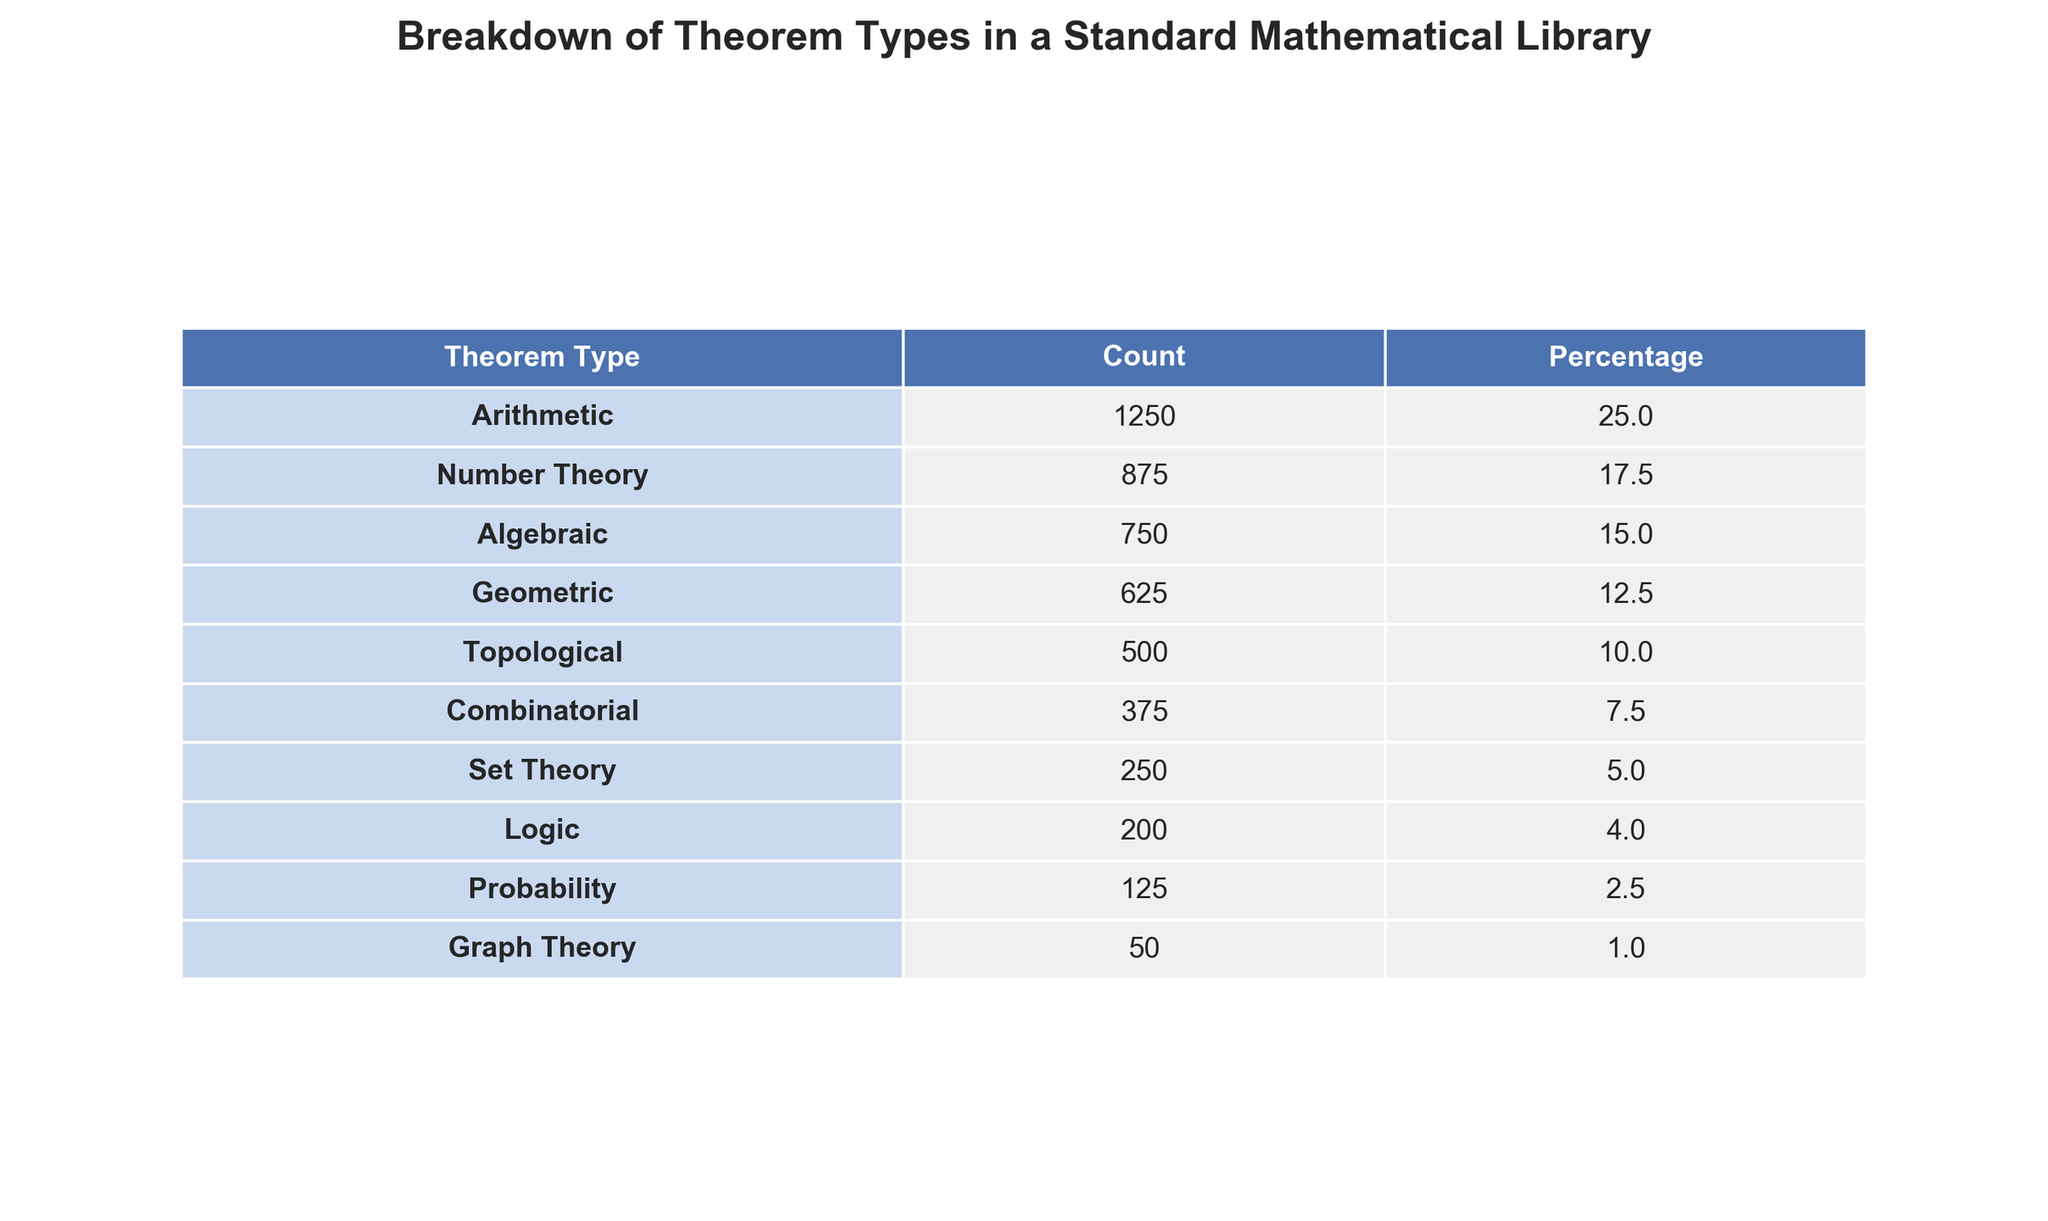What is the count of Theorems in Algebraic type? The count of Theorems in the Algebraic type is directly listed in the table under the Count column, which shows 750.
Answer: 750 Which theorem type has the highest percentage? By observing the Percentage column, Arithmetic has the highest value at 25.0%.
Answer: Arithmetic What is the total number of Theorems listed in the table? The total number of Theorems can be found by summing all the counts in the Count column: 1250 + 875 + 750 + 625 + 500 + 375 + 250 + 200 + 125 + 50 = 5000.
Answer: 5000 Is the count of Logic Theorems greater than that of Probability Theorems? Comparing the counts in the table, Logic has 200 Theorems and Probability has 125, thus 200 > 125 is true.
Answer: Yes What is the percentage difference between the highest and lowest theorem types? The highest theorem type, Arithmetic, has 25.0% and the lowest, Graph Theory, has 1.0%. The difference is 25.0% - 1.0% = 24.0%.
Answer: 24.0% If we combine the counts of Combinatorial and Set Theory files, what is the total? The count for Combinatorial is 375 and for Set Theory it is 250. Summing these gives 375 + 250 = 625.
Answer: 625 How many theorem types have a percentage greater than 10%? From the table, we see that there are five types (Arithmetic, Number Theory, Algebraic, Geometric, and Topological) with percentages greater than 10%.
Answer: 5 What percentage of Theorems does the group Algebraic and Geometric represent together? Algebraic has 15.0% and Geometric has 12.5%. Summing these gives 15.0% + 12.5% = 27.5%.
Answer: 27.5% Which theorem type has the smallest count? The count for Graph Theory is the smallest in the Count column, which is 50.
Answer: Graph Theory What fraction of the total theorems do Number Theory and Algebraic represent collectively? The combined count for Number Theory (875) and Algebraic (750) is 875 + 750 = 1625. To find the fraction of the total (5000), we compute 1625 / 5000 = 0.325 or 32.5%.
Answer: 32.5% 